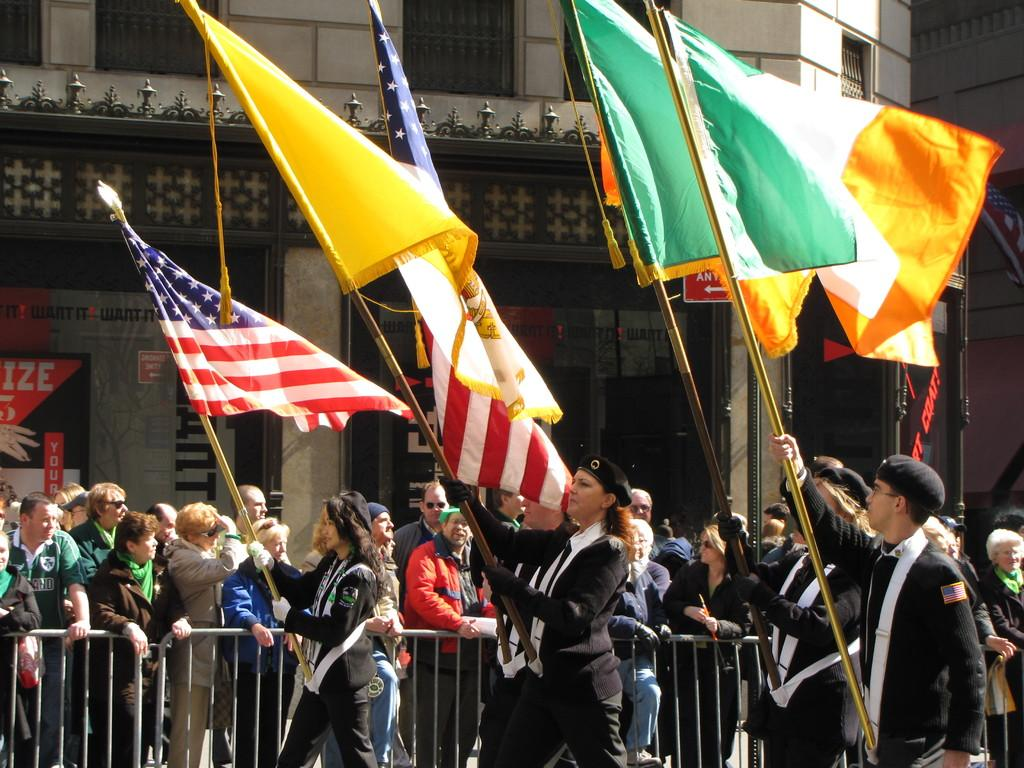How many people are in the image? There are people in the image, but the exact number is not specified. What are some people doing in the image? Some people are raising flags in the image. What objects are associated with the flags in the image? There are flags and poles in the image. What type of structure can be seen in the image? There is a building in the image. Can you describe the object in the image? There is an object in the image, but its specific nature is not mentioned. What invention is being used to capture the attention of the people in the image? There is no mention of any invention or device being used to capture the attention of the people in the image. 